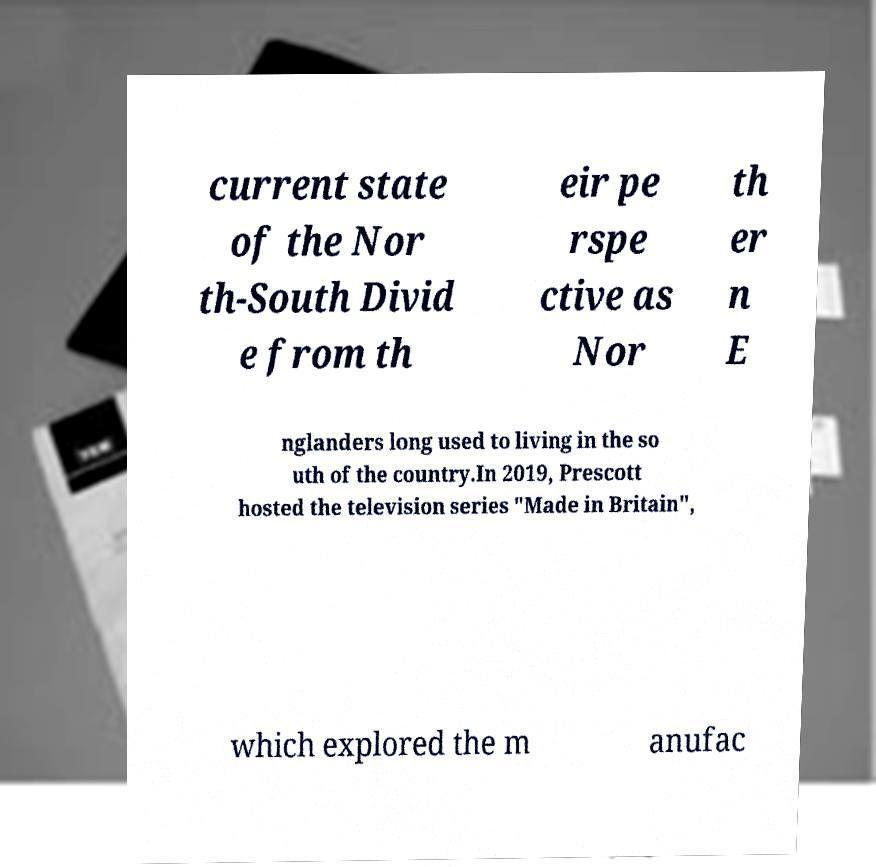Please read and relay the text visible in this image. What does it say? current state of the Nor th-South Divid e from th eir pe rspe ctive as Nor th er n E nglanders long used to living in the so uth of the country.In 2019, Prescott hosted the television series "Made in Britain", which explored the m anufac 